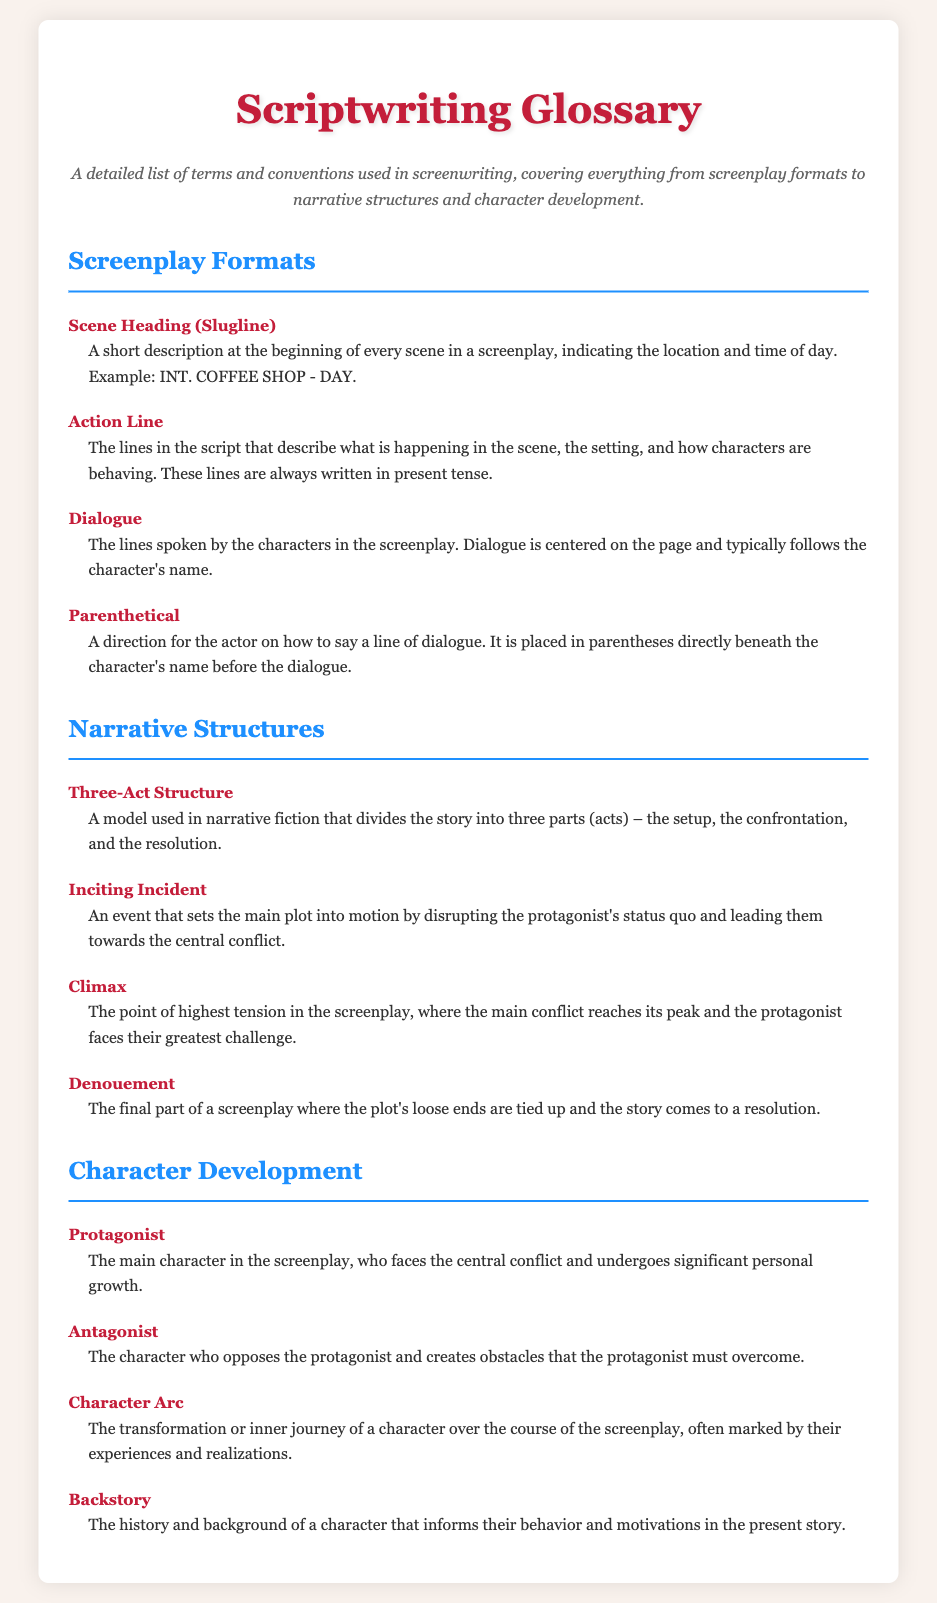What is a Scene Heading? A Scene Heading is a short description at the beginning of every scene in a screenplay, indicating the location and time of day.
Answer: A short description What does an Action Line describe? An Action Line describes what is happening in the scene, the setting, and how characters are behaving.
Answer: What is happening in the scene What is the purpose of Dialogue in a screenplay? Dialogue refers to the lines spoken by the characters in the screenplay.
Answer: Lines spoken by the characters What does the term Antagonist mean? An Antagonist is the character who opposes the protagonist and creates obstacles that the protagonist must overcome.
Answer: Opposes the protagonist How many parts are in the Three-Act Structure? The Three-Act Structure divides the story into three parts (acts).
Answer: Three parts What is an Inciting Incident? An Inciting Incident is an event that sets the main plot into motion by disrupting the protagonist's status quo.
Answer: An event that sets the main plot into motion What is a Character Arc? A Character Arc is the transformation or inner journey of a character over the course of the screenplay.
Answer: Transformation or inner journey What is Denouement? Denouement is the final part of a screenplay where the plot's loose ends are tied up.
Answer: Final part of a screenplay 